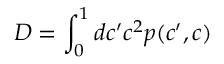Convert formula to latex. <formula><loc_0><loc_0><loc_500><loc_500>D = \int _ { 0 } ^ { 1 } d c ^ { \prime } c ^ { 2 } p ( c ^ { \prime } , c )</formula> 